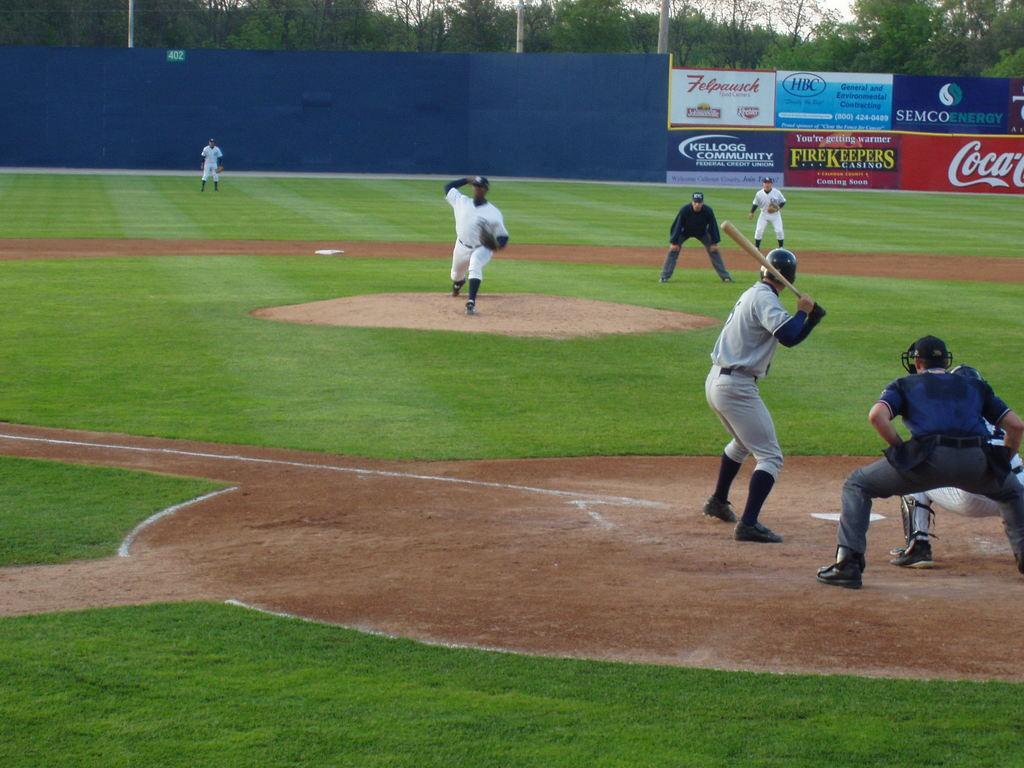In one or two sentences, can you explain what this image depicts? These people are playing baseball game. This man is holding a bat. Background there are hoardings and trees. 